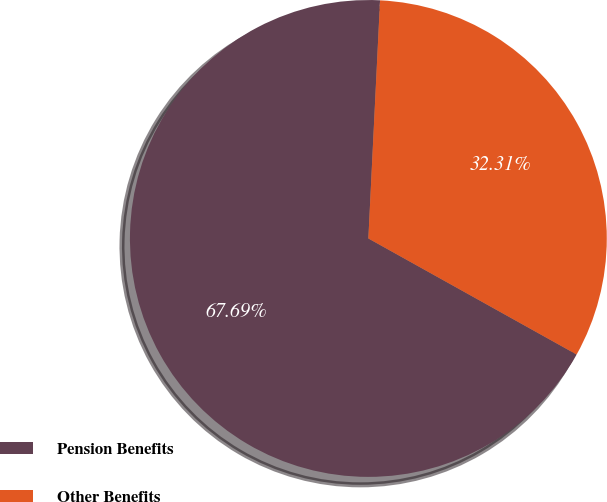Convert chart to OTSL. <chart><loc_0><loc_0><loc_500><loc_500><pie_chart><fcel>Pension Benefits<fcel>Other Benefits<nl><fcel>67.69%<fcel>32.31%<nl></chart> 